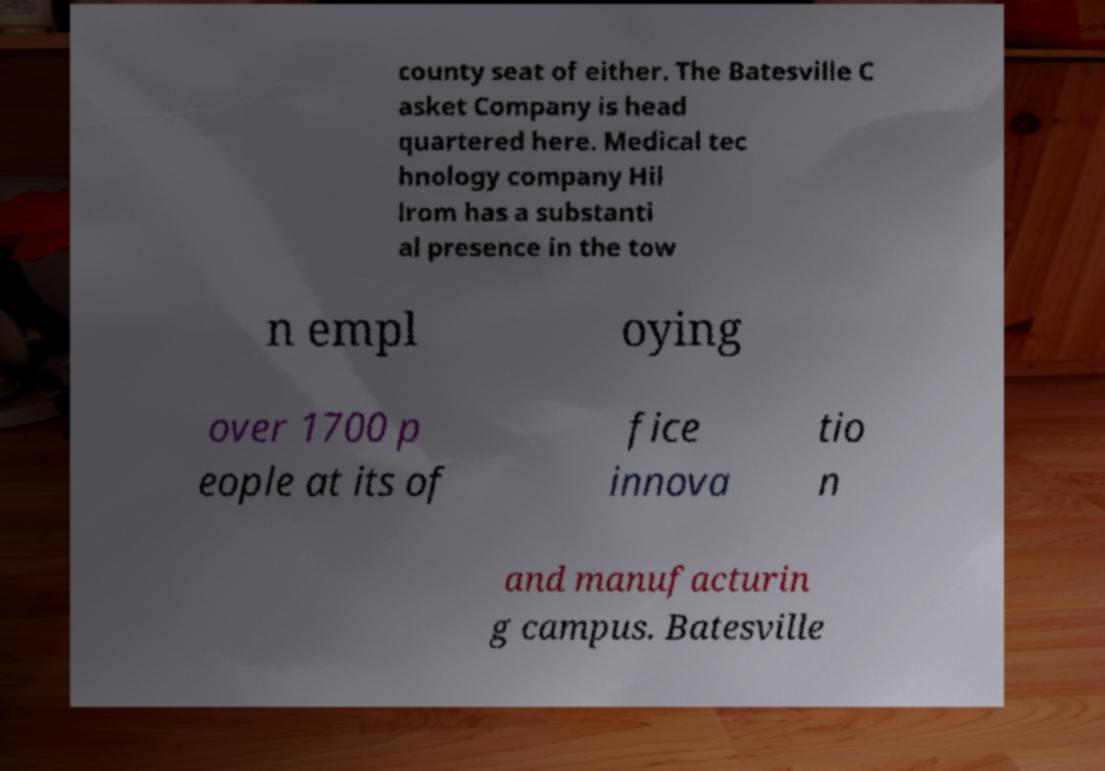Can you accurately transcribe the text from the provided image for me? county seat of either. The Batesville C asket Company is head quartered here. Medical tec hnology company Hil lrom has a substanti al presence in the tow n empl oying over 1700 p eople at its of fice innova tio n and manufacturin g campus. Batesville 